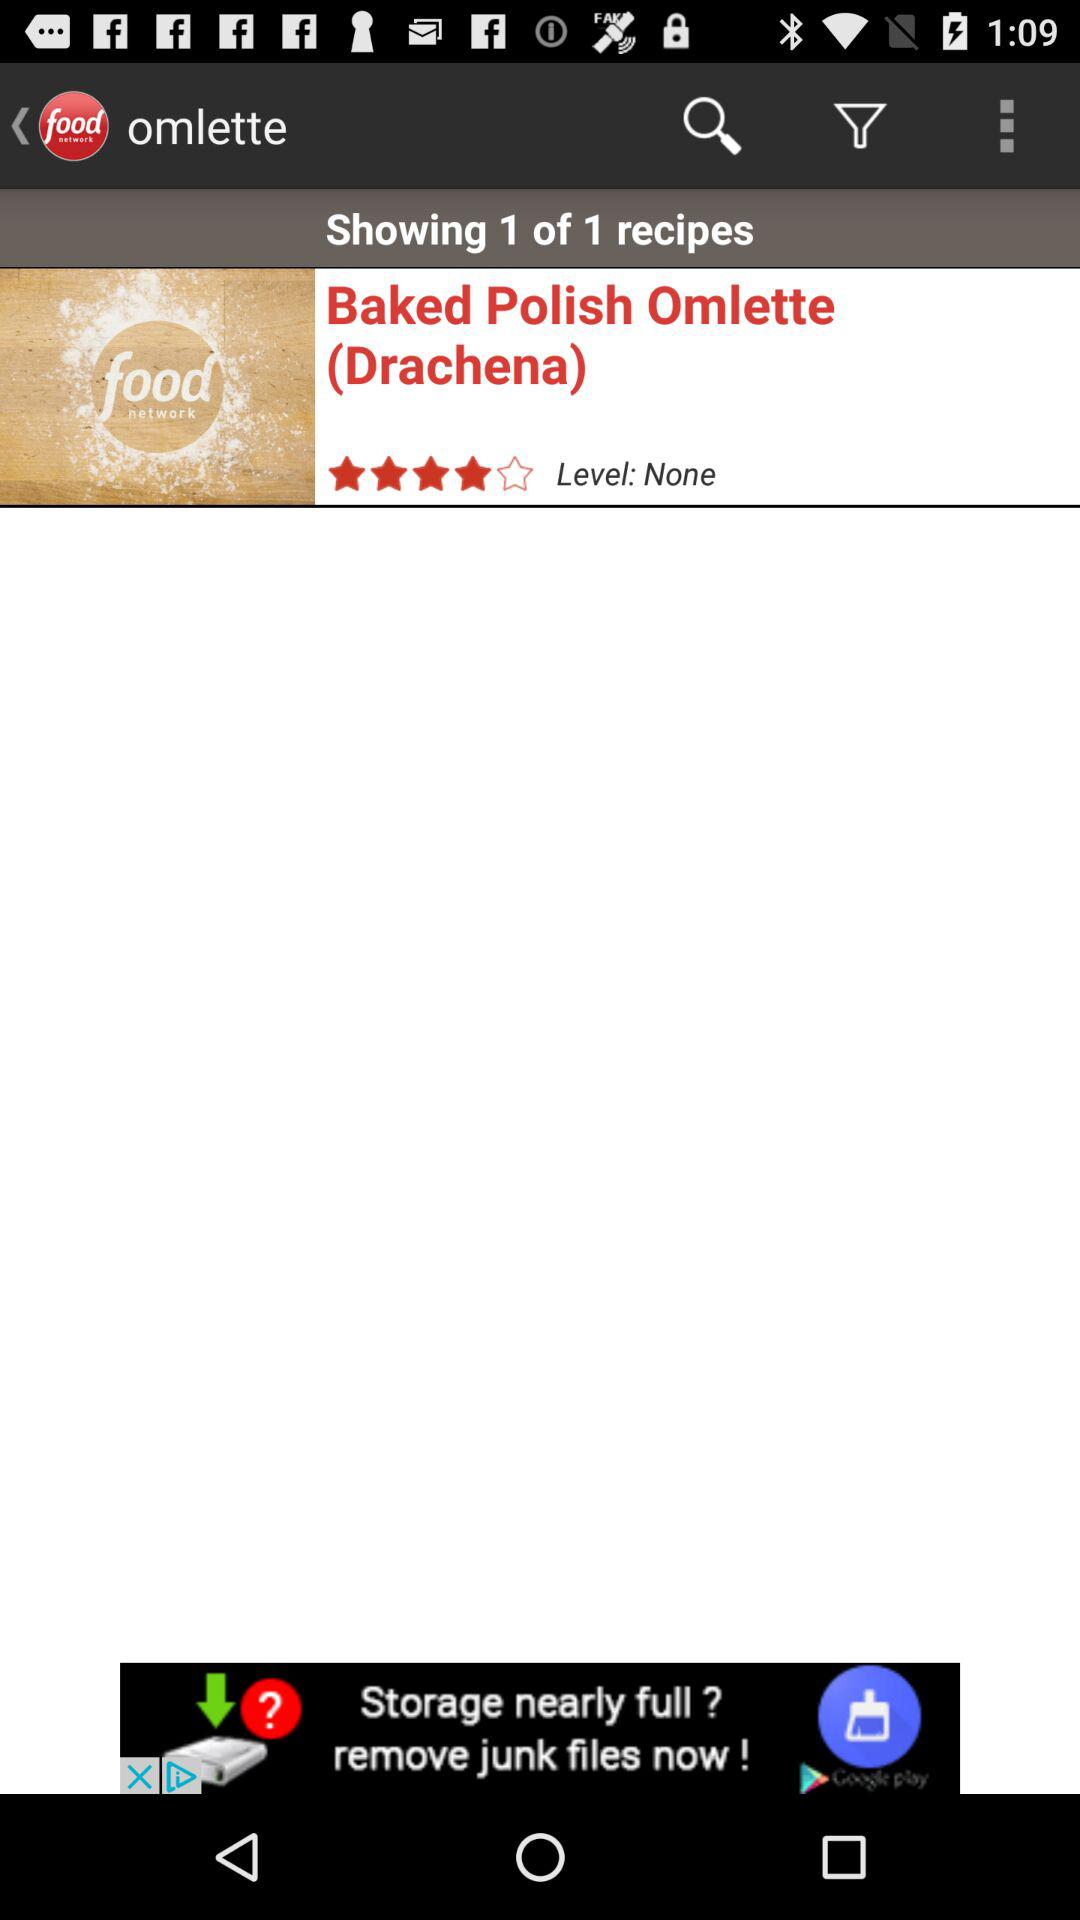What is the rating given? The rating is 4 stars. 